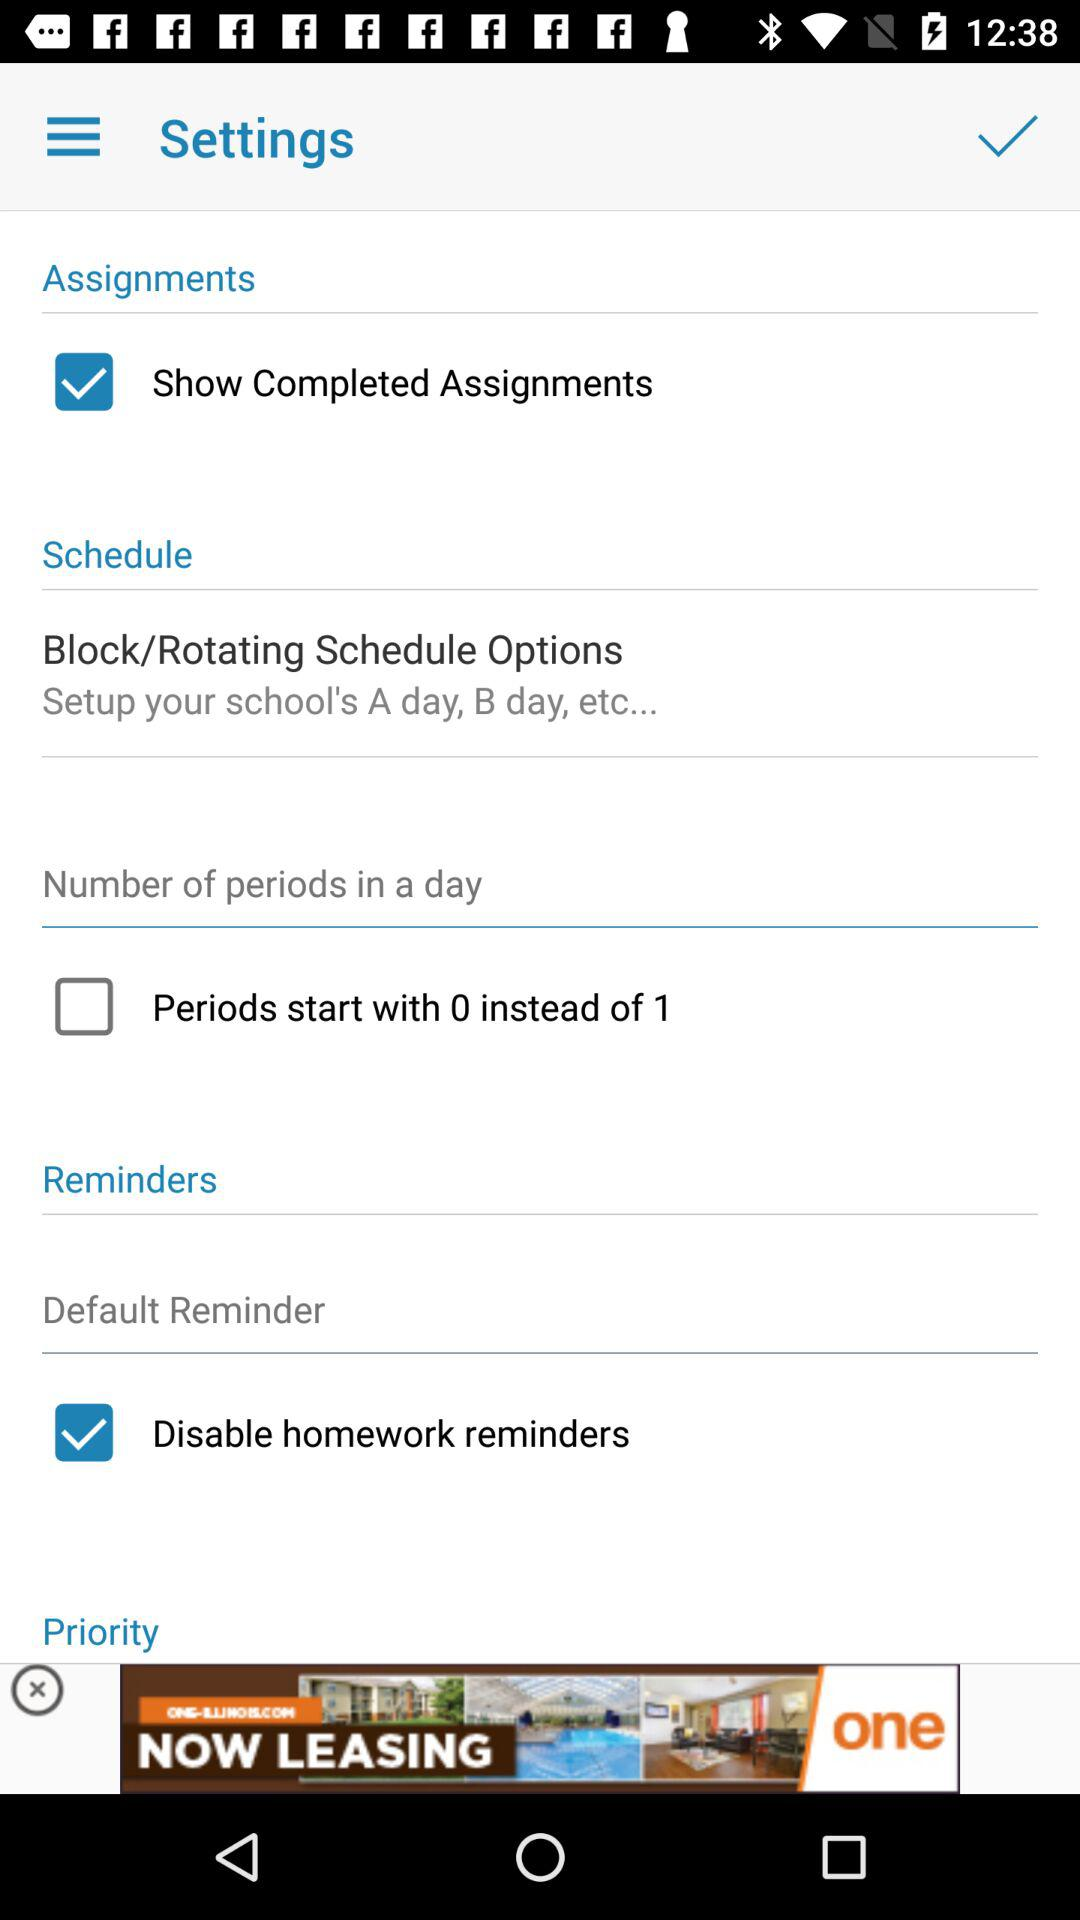Is "Default Reminder" selected or not selected?
When the provided information is insufficient, respond with <no answer>. <no answer> 